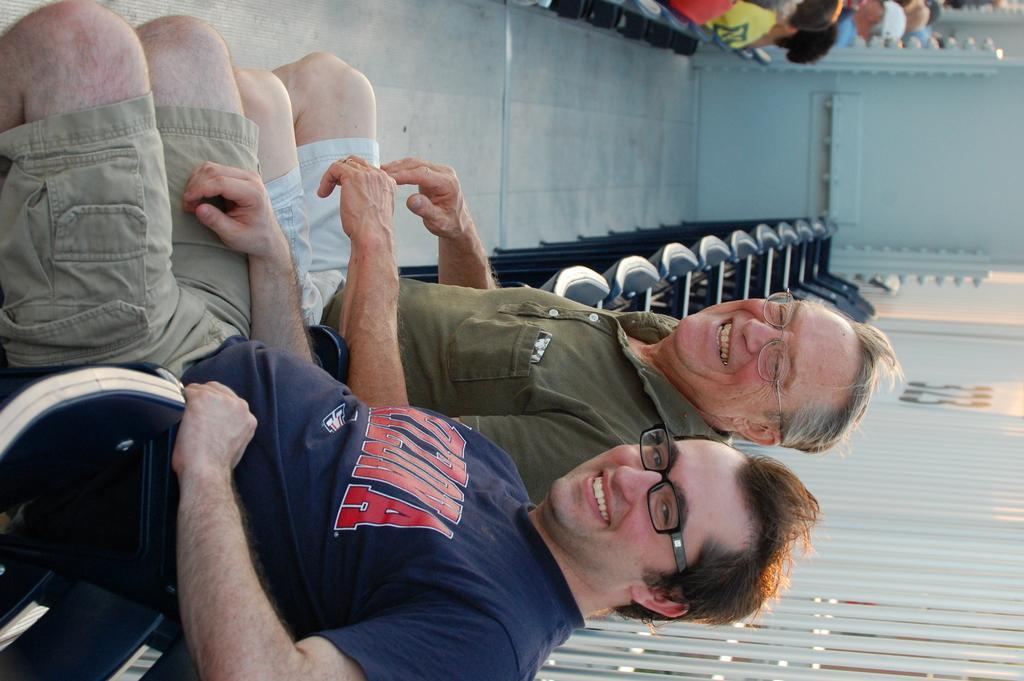Please provide a concise description of this image. At the bottom of this image, there are two persons, smiling and sitting. Beside them, there are chairs arranged and there is a fence. In the background, there are persons sitting and there is a white wall. 